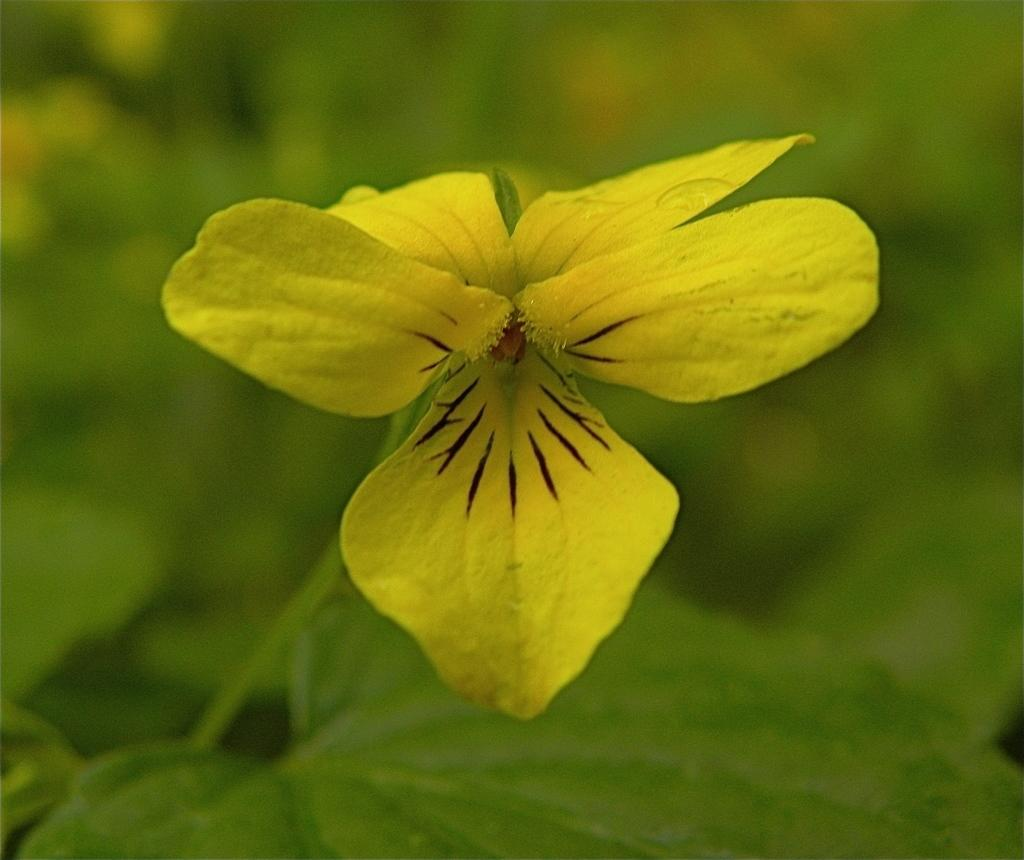What type of flower is in the image? There is a yellow flower with black stripes in the image. What can be seen in the background of the image? The background is green and blurred. How many snakes are slithering around the flower in the image? There are no snakes present in the image; it only features a yellow flower with black stripes. What direction is the point of the flower facing in the image? The image does not show a flower with a distinct point, so it is not possible to determine the direction it might be facing. 